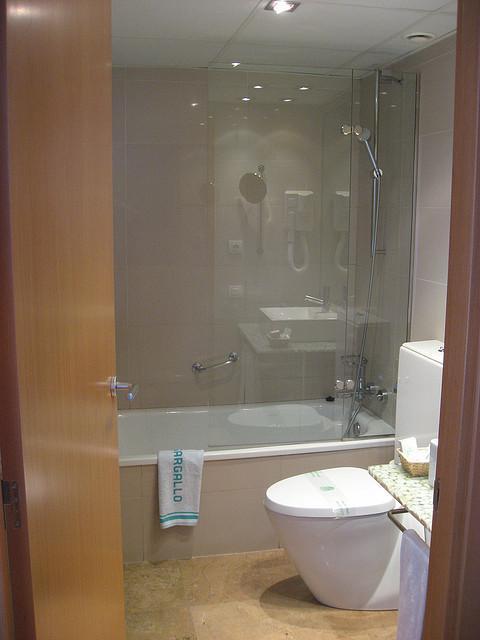How many people are carrying surfboards?
Give a very brief answer. 0. 